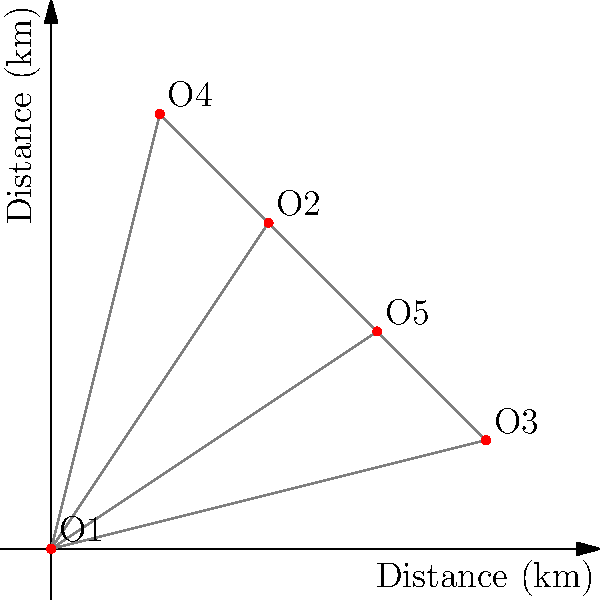Your company has five office locations (O1, O2, O3, O4, and O5) connected in a mesh network topology as shown in the diagram. To optimize network performance and reduce costs, you need to implement a Minimum Spanning Tree (MST). What is the total number of connections required in the optimized MST topology? To solve this problem, we'll follow these steps:

1. Understand the concept of Minimum Spanning Tree (MST):
   An MST is a subset of the edges in a network that connects all nodes with the minimum total edge weight, without creating cycles.

2. Count the number of offices:
   There are 5 offices in the network (O1, O2, O3, O4, and O5).

3. Apply the MST formula:
   For any connected graph with n nodes, the number of edges in its MST is always (n - 1).

4. Calculate the number of connections:
   Number of offices (n) = 5
   Number of connections in MST = n - 1 = 5 - 1 = 4

Therefore, the optimized MST topology for this network of 5 offices will require 4 connections.

This solution minimizes the total length of network cables needed while ensuring all offices remain connected, thus optimizing performance and reducing costs. As an experienced entrepreneur, you understand that this approach balances connectivity needs with cost-efficiency, providing long-term benefits for the company's network infrastructure.
Answer: 4 connections 